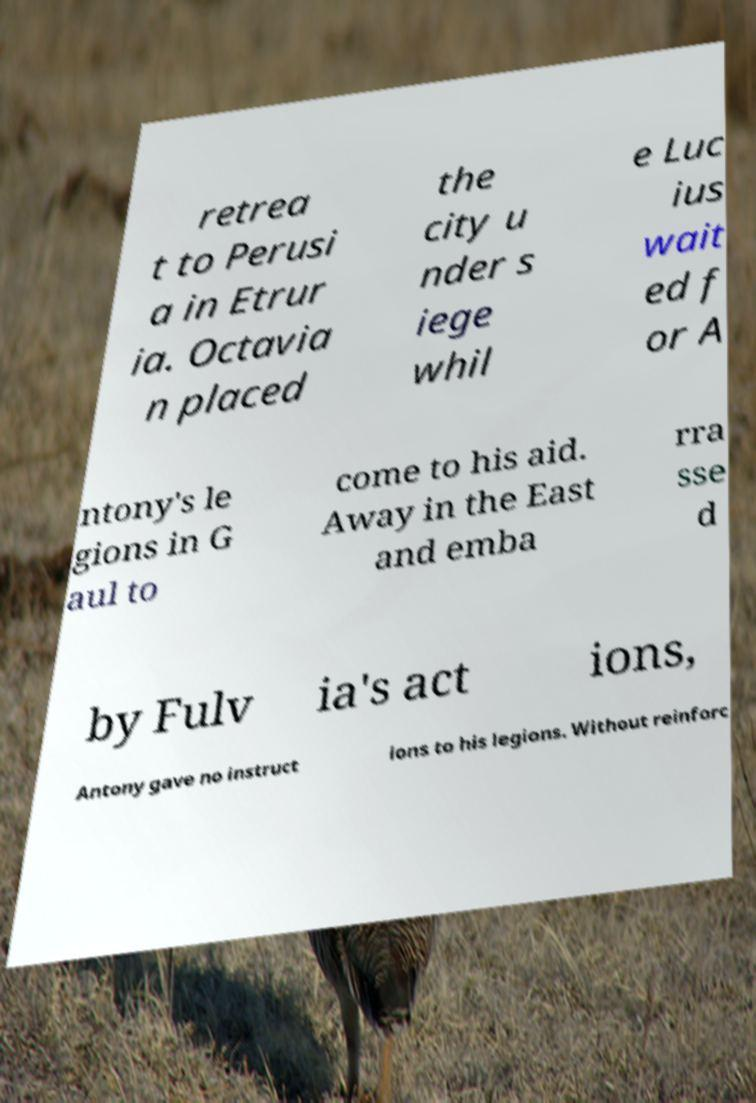Can you read and provide the text displayed in the image?This photo seems to have some interesting text. Can you extract and type it out for me? retrea t to Perusi a in Etrur ia. Octavia n placed the city u nder s iege whil e Luc ius wait ed f or A ntony's le gions in G aul to come to his aid. Away in the East and emba rra sse d by Fulv ia's act ions, Antony gave no instruct ions to his legions. Without reinforc 